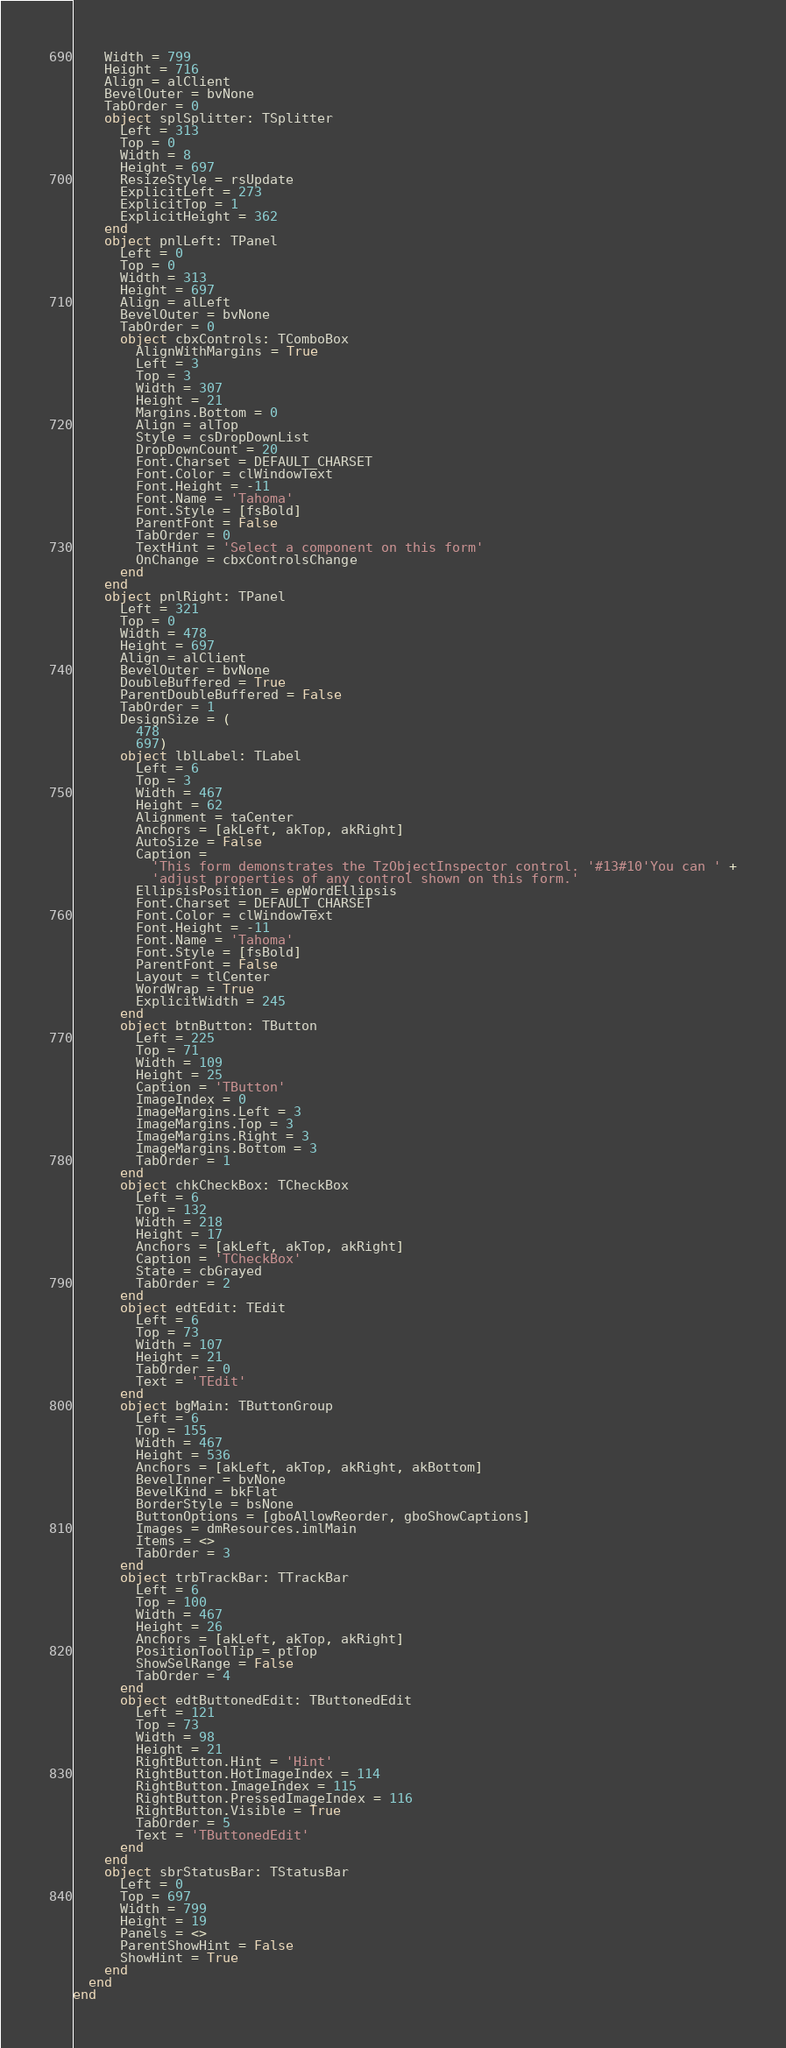<code> <loc_0><loc_0><loc_500><loc_500><_Pascal_>    Width = 799
    Height = 716
    Align = alClient
    BevelOuter = bvNone
    TabOrder = 0
    object splSplitter: TSplitter
      Left = 313
      Top = 0
      Width = 8
      Height = 697
      ResizeStyle = rsUpdate
      ExplicitLeft = 273
      ExplicitTop = 1
      ExplicitHeight = 362
    end
    object pnlLeft: TPanel
      Left = 0
      Top = 0
      Width = 313
      Height = 697
      Align = alLeft
      BevelOuter = bvNone
      TabOrder = 0
      object cbxControls: TComboBox
        AlignWithMargins = True
        Left = 3
        Top = 3
        Width = 307
        Height = 21
        Margins.Bottom = 0
        Align = alTop
        Style = csDropDownList
        DropDownCount = 20
        Font.Charset = DEFAULT_CHARSET
        Font.Color = clWindowText
        Font.Height = -11
        Font.Name = 'Tahoma'
        Font.Style = [fsBold]
        ParentFont = False
        TabOrder = 0
        TextHint = 'Select a component on this form'
        OnChange = cbxControlsChange
      end
    end
    object pnlRight: TPanel
      Left = 321
      Top = 0
      Width = 478
      Height = 697
      Align = alClient
      BevelOuter = bvNone
      DoubleBuffered = True
      ParentDoubleBuffered = False
      TabOrder = 1
      DesignSize = (
        478
        697)
      object lblLabel: TLabel
        Left = 6
        Top = 3
        Width = 467
        Height = 62
        Alignment = taCenter
        Anchors = [akLeft, akTop, akRight]
        AutoSize = False
        Caption = 
          'This form demonstrates the TzObjectInspector control. '#13#10'You can ' +
          'adjust properties of any control shown on this form.'
        EllipsisPosition = epWordEllipsis
        Font.Charset = DEFAULT_CHARSET
        Font.Color = clWindowText
        Font.Height = -11
        Font.Name = 'Tahoma'
        Font.Style = [fsBold]
        ParentFont = False
        Layout = tlCenter
        WordWrap = True
        ExplicitWidth = 245
      end
      object btnButton: TButton
        Left = 225
        Top = 71
        Width = 109
        Height = 25
        Caption = 'TButton'
        ImageIndex = 0
        ImageMargins.Left = 3
        ImageMargins.Top = 3
        ImageMargins.Right = 3
        ImageMargins.Bottom = 3
        TabOrder = 1
      end
      object chkCheckBox: TCheckBox
        Left = 6
        Top = 132
        Width = 218
        Height = 17
        Anchors = [akLeft, akTop, akRight]
        Caption = 'TCheckBox'
        State = cbGrayed
        TabOrder = 2
      end
      object edtEdit: TEdit
        Left = 6
        Top = 73
        Width = 107
        Height = 21
        TabOrder = 0
        Text = 'TEdit'
      end
      object bgMain: TButtonGroup
        Left = 6
        Top = 155
        Width = 467
        Height = 536
        Anchors = [akLeft, akTop, akRight, akBottom]
        BevelInner = bvNone
        BevelKind = bkFlat
        BorderStyle = bsNone
        ButtonOptions = [gboAllowReorder, gboShowCaptions]
        Images = dmResources.imlMain
        Items = <>
        TabOrder = 3
      end
      object trbTrackBar: TTrackBar
        Left = 6
        Top = 100
        Width = 467
        Height = 26
        Anchors = [akLeft, akTop, akRight]
        PositionToolTip = ptTop
        ShowSelRange = False
        TabOrder = 4
      end
      object edtButtonedEdit: TButtonedEdit
        Left = 121
        Top = 73
        Width = 98
        Height = 21
        RightButton.Hint = 'Hint'
        RightButton.HotImageIndex = 114
        RightButton.ImageIndex = 115
        RightButton.PressedImageIndex = 116
        RightButton.Visible = True
        TabOrder = 5
        Text = 'TButtonedEdit'
      end
    end
    object sbrStatusBar: TStatusBar
      Left = 0
      Top = 697
      Width = 799
      Height = 19
      Panels = <>
      ParentShowHint = False
      ShowHint = True
    end
  end
end
</code> 